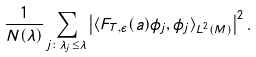Convert formula to latex. <formula><loc_0><loc_0><loc_500><loc_500>\frac { 1 } { N ( \lambda ) } \sum _ { j \colon \lambda _ { j } \leq \lambda } \left | \langle F _ { T , \epsilon } ( a ) \phi _ { j } , \phi _ { j } \rangle _ { L ^ { 2 } ( M ) } \right | ^ { 2 } .</formula> 